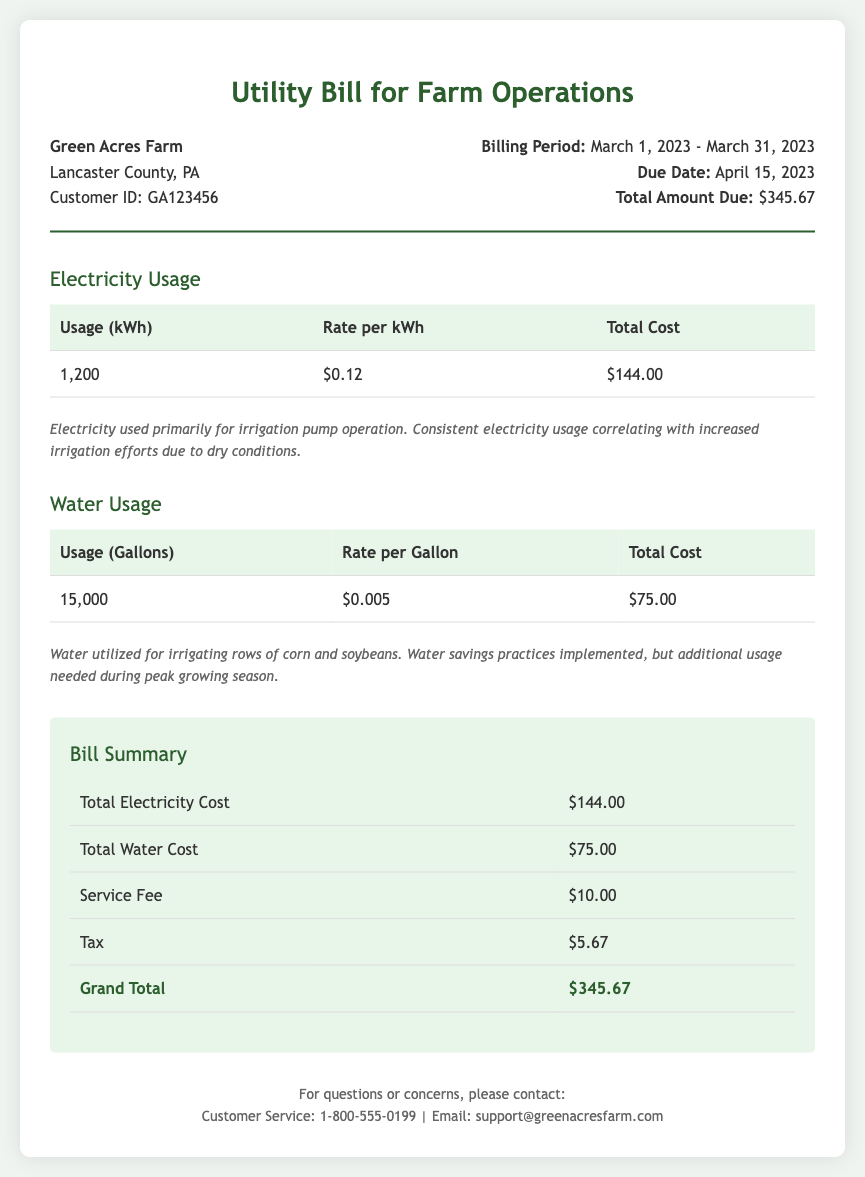What is the total amount due? The total amount due is stated in the bill as $345.67.
Answer: $345.67 What was the electricity usage in March 2023? The usage is detailed in the document as 1,200 kWh.
Answer: 1,200 kWh What is the rate per gallon of water? The rate is specified in the water usage table as $0.005.
Answer: $0.005 How much did the farm spend on electricity? The total cost of electricity is provided in the summary as $144.00.
Answer: $144.00 What is the billing period for this utility bill? The billing period is clearly stated as March 1, 2023 - March 31, 2023.
Answer: March 1, 2023 - March 31, 2023 Why was there an increase in electricity usage? The document notes consistent electricity usage correlating with increased irrigation efforts due to dry conditions.
Answer: Dry conditions What is included in the total cost for water? The total cost is the combination of usage, rate, and any additional fees related to water.
Answer: $75.00 When is the due date for this bill? The due date is mentioned in the billing information as April 15, 2023.
Answer: April 15, 2023 How many gallons of water were used? The usage is recorded as 15,000 gallons in the water usage section.
Answer: 15,000 gallons 